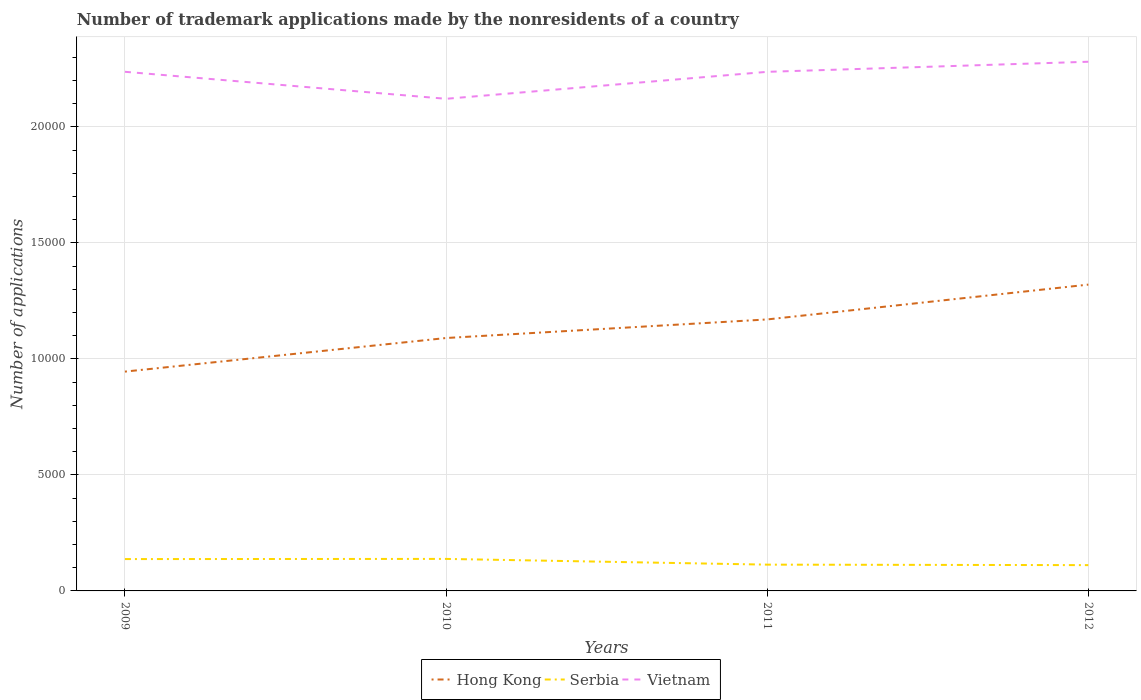Is the number of lines equal to the number of legend labels?
Your response must be concise. Yes. Across all years, what is the maximum number of trademark applications made by the nonresidents in Hong Kong?
Provide a short and direct response. 9454. In which year was the number of trademark applications made by the nonresidents in Vietnam maximum?
Keep it short and to the point. 2010. What is the total number of trademark applications made by the nonresidents in Vietnam in the graph?
Offer a terse response. -433. What is the difference between the highest and the second highest number of trademark applications made by the nonresidents in Hong Kong?
Give a very brief answer. 3750. What is the difference between the highest and the lowest number of trademark applications made by the nonresidents in Serbia?
Your response must be concise. 2. Is the number of trademark applications made by the nonresidents in Serbia strictly greater than the number of trademark applications made by the nonresidents in Hong Kong over the years?
Offer a terse response. Yes. What is the difference between two consecutive major ticks on the Y-axis?
Ensure brevity in your answer.  5000. Are the values on the major ticks of Y-axis written in scientific E-notation?
Your answer should be compact. No. Does the graph contain grids?
Offer a terse response. Yes. How are the legend labels stacked?
Ensure brevity in your answer.  Horizontal. What is the title of the graph?
Provide a succinct answer. Number of trademark applications made by the nonresidents of a country. Does "Uruguay" appear as one of the legend labels in the graph?
Ensure brevity in your answer.  No. What is the label or title of the Y-axis?
Your answer should be very brief. Number of applications. What is the Number of applications of Hong Kong in 2009?
Provide a succinct answer. 9454. What is the Number of applications in Serbia in 2009?
Provide a succinct answer. 1373. What is the Number of applications of Vietnam in 2009?
Offer a terse response. 2.24e+04. What is the Number of applications of Hong Kong in 2010?
Offer a very short reply. 1.09e+04. What is the Number of applications of Serbia in 2010?
Make the answer very short. 1380. What is the Number of applications in Vietnam in 2010?
Make the answer very short. 2.12e+04. What is the Number of applications in Hong Kong in 2011?
Provide a succinct answer. 1.17e+04. What is the Number of applications in Serbia in 2011?
Keep it short and to the point. 1133. What is the Number of applications of Vietnam in 2011?
Your answer should be very brief. 2.24e+04. What is the Number of applications of Hong Kong in 2012?
Offer a terse response. 1.32e+04. What is the Number of applications in Serbia in 2012?
Provide a succinct answer. 1112. What is the Number of applications of Vietnam in 2012?
Provide a succinct answer. 2.28e+04. Across all years, what is the maximum Number of applications of Hong Kong?
Your response must be concise. 1.32e+04. Across all years, what is the maximum Number of applications in Serbia?
Make the answer very short. 1380. Across all years, what is the maximum Number of applications in Vietnam?
Keep it short and to the point. 2.28e+04. Across all years, what is the minimum Number of applications in Hong Kong?
Make the answer very short. 9454. Across all years, what is the minimum Number of applications in Serbia?
Your answer should be very brief. 1112. Across all years, what is the minimum Number of applications in Vietnam?
Your answer should be compact. 2.12e+04. What is the total Number of applications of Hong Kong in the graph?
Ensure brevity in your answer.  4.53e+04. What is the total Number of applications in Serbia in the graph?
Give a very brief answer. 4998. What is the total Number of applications in Vietnam in the graph?
Your answer should be compact. 8.88e+04. What is the difference between the Number of applications of Hong Kong in 2009 and that in 2010?
Your answer should be compact. -1448. What is the difference between the Number of applications in Vietnam in 2009 and that in 2010?
Keep it short and to the point. 1164. What is the difference between the Number of applications in Hong Kong in 2009 and that in 2011?
Keep it short and to the point. -2249. What is the difference between the Number of applications of Serbia in 2009 and that in 2011?
Offer a terse response. 240. What is the difference between the Number of applications of Vietnam in 2009 and that in 2011?
Make the answer very short. 2. What is the difference between the Number of applications in Hong Kong in 2009 and that in 2012?
Offer a terse response. -3750. What is the difference between the Number of applications in Serbia in 2009 and that in 2012?
Your response must be concise. 261. What is the difference between the Number of applications of Vietnam in 2009 and that in 2012?
Your answer should be compact. -433. What is the difference between the Number of applications in Hong Kong in 2010 and that in 2011?
Your answer should be compact. -801. What is the difference between the Number of applications in Serbia in 2010 and that in 2011?
Your answer should be very brief. 247. What is the difference between the Number of applications in Vietnam in 2010 and that in 2011?
Give a very brief answer. -1162. What is the difference between the Number of applications in Hong Kong in 2010 and that in 2012?
Keep it short and to the point. -2302. What is the difference between the Number of applications of Serbia in 2010 and that in 2012?
Keep it short and to the point. 268. What is the difference between the Number of applications in Vietnam in 2010 and that in 2012?
Provide a short and direct response. -1597. What is the difference between the Number of applications of Hong Kong in 2011 and that in 2012?
Offer a terse response. -1501. What is the difference between the Number of applications in Vietnam in 2011 and that in 2012?
Provide a succinct answer. -435. What is the difference between the Number of applications of Hong Kong in 2009 and the Number of applications of Serbia in 2010?
Offer a terse response. 8074. What is the difference between the Number of applications of Hong Kong in 2009 and the Number of applications of Vietnam in 2010?
Offer a terse response. -1.18e+04. What is the difference between the Number of applications of Serbia in 2009 and the Number of applications of Vietnam in 2010?
Ensure brevity in your answer.  -1.98e+04. What is the difference between the Number of applications in Hong Kong in 2009 and the Number of applications in Serbia in 2011?
Keep it short and to the point. 8321. What is the difference between the Number of applications in Hong Kong in 2009 and the Number of applications in Vietnam in 2011?
Your response must be concise. -1.29e+04. What is the difference between the Number of applications of Serbia in 2009 and the Number of applications of Vietnam in 2011?
Your answer should be compact. -2.10e+04. What is the difference between the Number of applications in Hong Kong in 2009 and the Number of applications in Serbia in 2012?
Your answer should be very brief. 8342. What is the difference between the Number of applications of Hong Kong in 2009 and the Number of applications of Vietnam in 2012?
Ensure brevity in your answer.  -1.34e+04. What is the difference between the Number of applications of Serbia in 2009 and the Number of applications of Vietnam in 2012?
Provide a short and direct response. -2.14e+04. What is the difference between the Number of applications of Hong Kong in 2010 and the Number of applications of Serbia in 2011?
Provide a succinct answer. 9769. What is the difference between the Number of applications in Hong Kong in 2010 and the Number of applications in Vietnam in 2011?
Offer a terse response. -1.15e+04. What is the difference between the Number of applications in Serbia in 2010 and the Number of applications in Vietnam in 2011?
Keep it short and to the point. -2.10e+04. What is the difference between the Number of applications in Hong Kong in 2010 and the Number of applications in Serbia in 2012?
Make the answer very short. 9790. What is the difference between the Number of applications of Hong Kong in 2010 and the Number of applications of Vietnam in 2012?
Provide a short and direct response. -1.19e+04. What is the difference between the Number of applications in Serbia in 2010 and the Number of applications in Vietnam in 2012?
Make the answer very short. -2.14e+04. What is the difference between the Number of applications in Hong Kong in 2011 and the Number of applications in Serbia in 2012?
Offer a very short reply. 1.06e+04. What is the difference between the Number of applications in Hong Kong in 2011 and the Number of applications in Vietnam in 2012?
Your answer should be compact. -1.11e+04. What is the difference between the Number of applications of Serbia in 2011 and the Number of applications of Vietnam in 2012?
Ensure brevity in your answer.  -2.17e+04. What is the average Number of applications of Hong Kong per year?
Provide a succinct answer. 1.13e+04. What is the average Number of applications of Serbia per year?
Give a very brief answer. 1249.5. What is the average Number of applications of Vietnam per year?
Your response must be concise. 2.22e+04. In the year 2009, what is the difference between the Number of applications in Hong Kong and Number of applications in Serbia?
Provide a short and direct response. 8081. In the year 2009, what is the difference between the Number of applications of Hong Kong and Number of applications of Vietnam?
Ensure brevity in your answer.  -1.29e+04. In the year 2009, what is the difference between the Number of applications of Serbia and Number of applications of Vietnam?
Make the answer very short. -2.10e+04. In the year 2010, what is the difference between the Number of applications of Hong Kong and Number of applications of Serbia?
Provide a succinct answer. 9522. In the year 2010, what is the difference between the Number of applications of Hong Kong and Number of applications of Vietnam?
Offer a very short reply. -1.03e+04. In the year 2010, what is the difference between the Number of applications of Serbia and Number of applications of Vietnam?
Keep it short and to the point. -1.98e+04. In the year 2011, what is the difference between the Number of applications of Hong Kong and Number of applications of Serbia?
Keep it short and to the point. 1.06e+04. In the year 2011, what is the difference between the Number of applications of Hong Kong and Number of applications of Vietnam?
Your response must be concise. -1.07e+04. In the year 2011, what is the difference between the Number of applications of Serbia and Number of applications of Vietnam?
Offer a very short reply. -2.12e+04. In the year 2012, what is the difference between the Number of applications in Hong Kong and Number of applications in Serbia?
Your answer should be compact. 1.21e+04. In the year 2012, what is the difference between the Number of applications of Hong Kong and Number of applications of Vietnam?
Provide a succinct answer. -9607. In the year 2012, what is the difference between the Number of applications of Serbia and Number of applications of Vietnam?
Keep it short and to the point. -2.17e+04. What is the ratio of the Number of applications in Hong Kong in 2009 to that in 2010?
Provide a succinct answer. 0.87. What is the ratio of the Number of applications of Serbia in 2009 to that in 2010?
Provide a succinct answer. 0.99. What is the ratio of the Number of applications of Vietnam in 2009 to that in 2010?
Give a very brief answer. 1.05. What is the ratio of the Number of applications of Hong Kong in 2009 to that in 2011?
Provide a succinct answer. 0.81. What is the ratio of the Number of applications of Serbia in 2009 to that in 2011?
Offer a terse response. 1.21. What is the ratio of the Number of applications in Vietnam in 2009 to that in 2011?
Ensure brevity in your answer.  1. What is the ratio of the Number of applications in Hong Kong in 2009 to that in 2012?
Provide a short and direct response. 0.72. What is the ratio of the Number of applications in Serbia in 2009 to that in 2012?
Offer a terse response. 1.23. What is the ratio of the Number of applications in Vietnam in 2009 to that in 2012?
Your answer should be compact. 0.98. What is the ratio of the Number of applications of Hong Kong in 2010 to that in 2011?
Make the answer very short. 0.93. What is the ratio of the Number of applications in Serbia in 2010 to that in 2011?
Ensure brevity in your answer.  1.22. What is the ratio of the Number of applications of Vietnam in 2010 to that in 2011?
Make the answer very short. 0.95. What is the ratio of the Number of applications of Hong Kong in 2010 to that in 2012?
Keep it short and to the point. 0.83. What is the ratio of the Number of applications in Serbia in 2010 to that in 2012?
Give a very brief answer. 1.24. What is the ratio of the Number of applications in Hong Kong in 2011 to that in 2012?
Give a very brief answer. 0.89. What is the ratio of the Number of applications in Serbia in 2011 to that in 2012?
Keep it short and to the point. 1.02. What is the ratio of the Number of applications in Vietnam in 2011 to that in 2012?
Offer a terse response. 0.98. What is the difference between the highest and the second highest Number of applications of Hong Kong?
Ensure brevity in your answer.  1501. What is the difference between the highest and the second highest Number of applications in Serbia?
Give a very brief answer. 7. What is the difference between the highest and the second highest Number of applications in Vietnam?
Provide a succinct answer. 433. What is the difference between the highest and the lowest Number of applications of Hong Kong?
Give a very brief answer. 3750. What is the difference between the highest and the lowest Number of applications of Serbia?
Offer a very short reply. 268. What is the difference between the highest and the lowest Number of applications of Vietnam?
Your answer should be compact. 1597. 